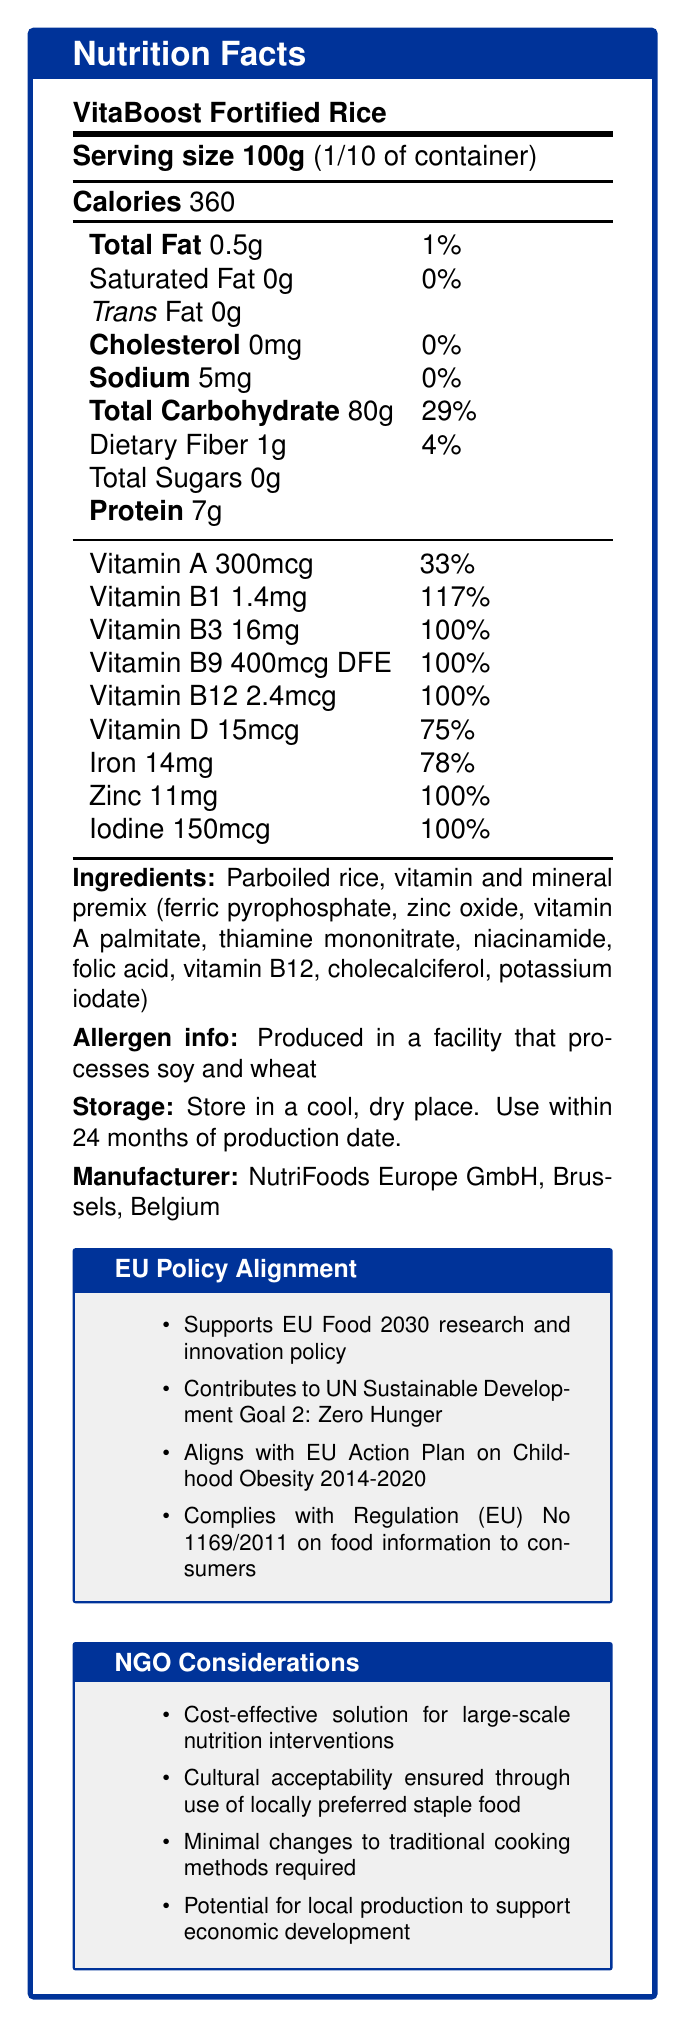What is the serving size of VitaBoost Fortified Rice? The serving size is explicitly mentioned in the document as "Serving size 100g."
Answer: 100g How many calories are there per serving of VitaBoost Fortified Rice? The number of calories per serving is clearly stated in the section labeled "Calories" as 360.
Answer: 360 Which vitamin is provided at the highest daily value percentage in VitaBoost Fortified Rice? Vitamin B1 is provided at 117% daily value, which is the highest percentage listed for any vitamin or mineral.
Answer: Vitamin B1 How much iron does one serving of VitaBoost Fortified Rice contain? The document lists iron content as 14mg per serving.
Answer: 14mg Which company manufactures VitaBoost Fortified Rice? The manufacturer section of the document states that the product is made by NutriFoods Europe GmbH, Brussels, Belgium.
Answer: NutriFoods Europe GmbH Which of the following vitamins is NOT listed on the Nutrition Facts Label of VitaBoost Fortified Rice? A. Vitamin C B. Vitamin D C. Vitamin B12 Vitamin C is not listed anywhere on the Nutrition Facts Label.
Answer: A. Vitamin C The product aligns with which EU regulation about food information to consumers? A. Regulation (EU) No 1924/2006 B. Regulation (EU) No 1169/2011 C. Regulation (EU) No 432/2012 The document specifies that the product complies with Regulation (EU) No 1169/2011 on food information to consumers.
Answer: B. Regulation (EU) No 1169/2011 Does the product contain any trans fats? The document clearly states "Trans Fat 0g," indicating that there are no trans fats in the product.
Answer: No Summarize the main purpose of the VitaBoost Fortified Rice as described in the document. The product description and additional boxes indicate it is intended to combat nutritional deficiencies while aligning with various policies.
Answer: VitaBoost Fortified Rice is a fortified food product designed to address nutritional deficiencies in vulnerable populations. It contains a high amount of essential vitamins and minerals, meets EU fortification standards, and aligns with various EU policies and guidelines. It is manufactured by NutriFoods Europe GmbH and is culturally suitable for large-scale nutritional interventions. Can VitaBoost Fortified Rice be stored in any condition? The storage instructions clearly state that it should be stored in a cool, dry place and used within 24 months of the production date.
Answer: No Is this product suitable for someone with a soy allergy? The allergen information indicates that the product is produced in a facility that processes soy, making it unsuitable for someone with a soy allergy.
Answer: No How does the product contribute to the UN Sustainable Development Goals? The EU Policy Alignment section explicitly states that the product contributes to UN Sustainable Development Goal 2: Zero Hunger.
Answer: It contributes to UN Sustainable Development Goal 2: Zero Hunger Does the VitaBoost Fortified Rice contain any preservatives? The document does not provide information regarding the presence or absence of preservatives in the product.
Answer: Cannot be determined 